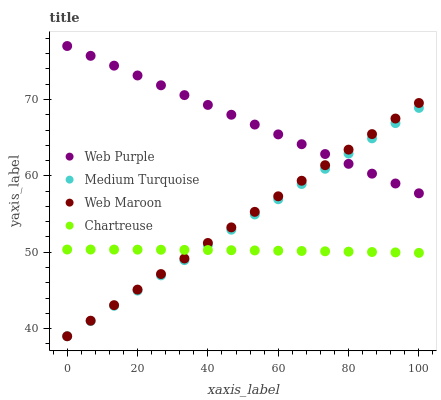Does Chartreuse have the minimum area under the curve?
Answer yes or no. Yes. Does Web Purple have the maximum area under the curve?
Answer yes or no. Yes. Does Web Maroon have the minimum area under the curve?
Answer yes or no. No. Does Web Maroon have the maximum area under the curve?
Answer yes or no. No. Is Medium Turquoise the smoothest?
Answer yes or no. Yes. Is Chartreuse the roughest?
Answer yes or no. Yes. Is Web Maroon the smoothest?
Answer yes or no. No. Is Web Maroon the roughest?
Answer yes or no. No. Does Web Maroon have the lowest value?
Answer yes or no. Yes. Does Chartreuse have the lowest value?
Answer yes or no. No. Does Web Purple have the highest value?
Answer yes or no. Yes. Does Web Maroon have the highest value?
Answer yes or no. No. Is Chartreuse less than Web Purple?
Answer yes or no. Yes. Is Web Purple greater than Chartreuse?
Answer yes or no. Yes. Does Web Purple intersect Medium Turquoise?
Answer yes or no. Yes. Is Web Purple less than Medium Turquoise?
Answer yes or no. No. Is Web Purple greater than Medium Turquoise?
Answer yes or no. No. Does Chartreuse intersect Web Purple?
Answer yes or no. No. 